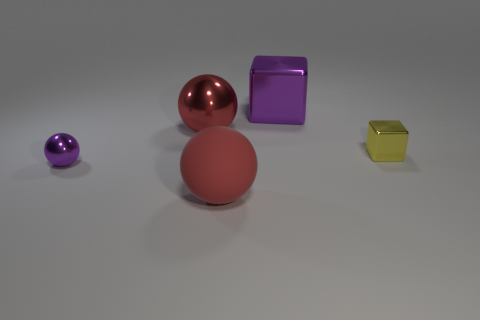Subtract all red spheres. How many were subtracted if there are1red spheres left? 1 Add 1 large shiny objects. How many objects exist? 6 Subtract all cubes. How many objects are left? 3 Add 3 tiny purple spheres. How many tiny purple spheres are left? 4 Add 5 large green blocks. How many large green blocks exist? 5 Subtract 0 blue balls. How many objects are left? 5 Subtract all large blocks. Subtract all tiny purple objects. How many objects are left? 3 